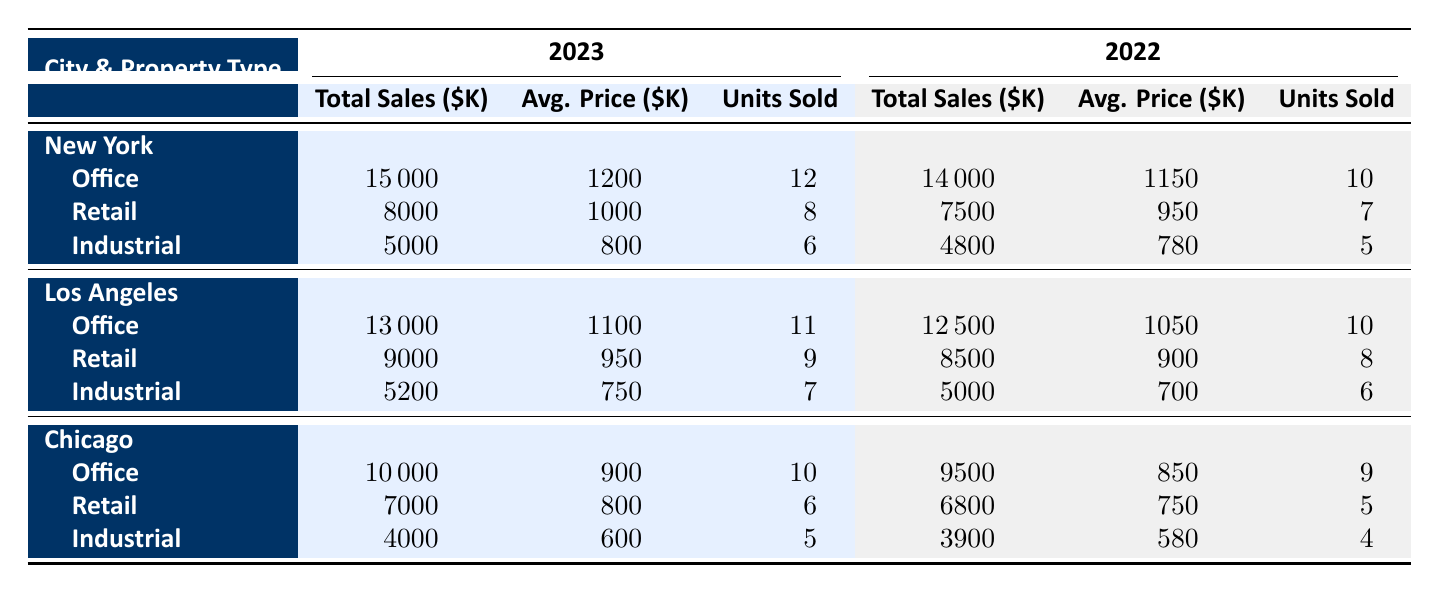What were the total sales for Office properties in New York in 2023? According to the table, the total sales for Office properties in New York for 2023 are listed as 15000.
Answer: 15000 What is the average price of Retail properties in Los Angeles in 2022? The table shows the average price for Retail properties in Los Angeles for 2022 is 900.
Answer: 900 Which city had the highest total sales for Industrial properties in 2023? By comparing the total sales for Industrial properties: New York (5000), Los Angeles (5200), and Chicago (4000), Los Angeles has the highest total sales at 5200.
Answer: Los Angeles Is the average price for Office properties in Chicago lower in 2022 than in 2023? The average price for Office properties in Chicago is 850 in 2022 and 900 in 2023. Since 850 < 900, it is false that it is lower in 2022.
Answer: No What was the percentage increase in total sales for Retail properties in New York from 2022 to 2023? The total sales for Retail properties in New York were 7500 in 2022 and increased to 8000 in 2023. The increase is 8000 - 7500 = 500. The percentage increase is (500 / 7500) * 100 = 6.67%.
Answer: 6.67% Which city had the least number of units sold for Industrial properties in 2023? The units sold for Industrial properties are New York (6), Los Angeles (7), and Chicago (5). Chicago has the least units sold at 5.
Answer: Chicago How much did total sales for Office properties in New York increase from 2022 to 2023? The total sales for Office properties in New York were 14000 in 2022 and increased to 15000 in 2023. The increase is 15000 - 14000 = 1000.
Answer: 1000 Did Miami have any sales recorded in this table for either year? Miami is not listed in the table under either year, indicating that there were no recorded sales for Miami.
Answer: No What is the total sales of all property types combined for Chicago in 2023? The total sales for all properties in Chicago in 2023 are (10000 for Office) + (7000 for Retail) + (4000 for Industrial). Therefore, the total is 10000 + 7000 + 4000 = 21000.
Answer: 21000 